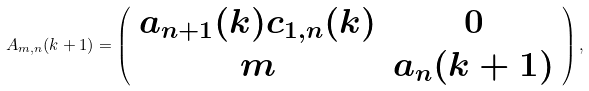Convert formula to latex. <formula><loc_0><loc_0><loc_500><loc_500>A _ { m , n } ( k + 1 ) = \left ( \begin{array} { c c } a _ { n + 1 } ( k ) c _ { 1 , n } ( k ) & 0 \\ m & a _ { n } ( k + 1 ) \end{array} \right ) ,</formula> 